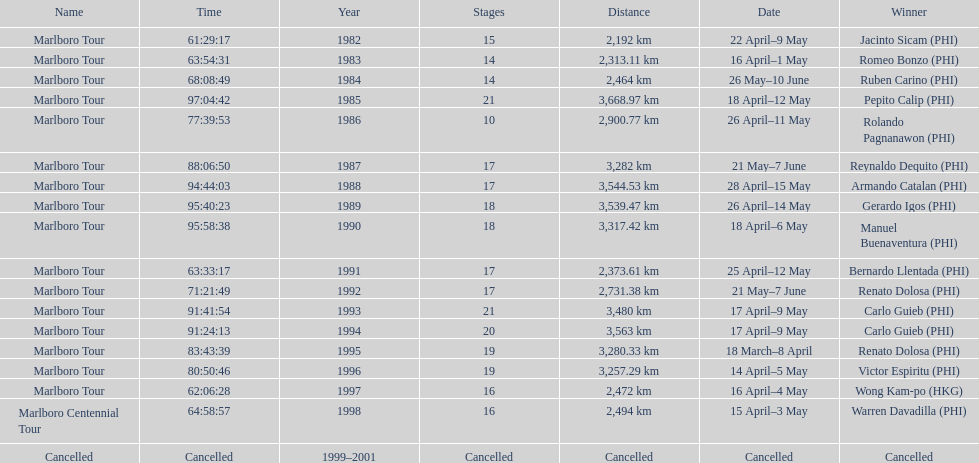Who won the most marlboro tours? Carlo Guieb. 